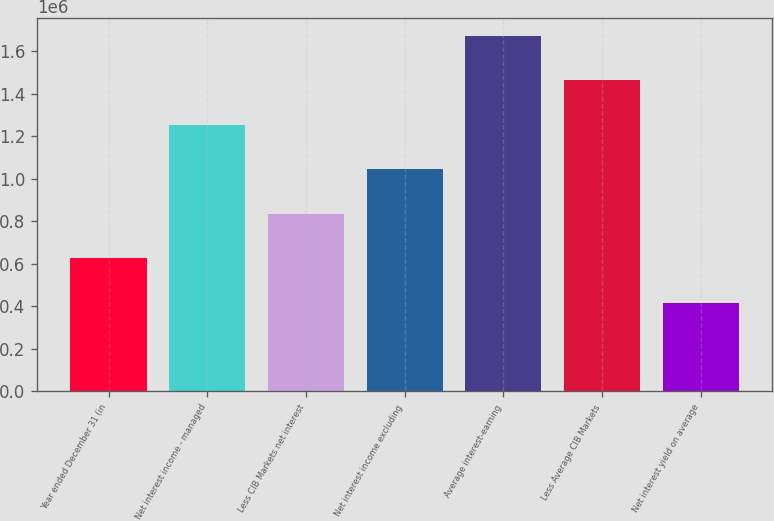Convert chart to OTSL. <chart><loc_0><loc_0><loc_500><loc_500><bar_chart><fcel>Year ended December 31 (in<fcel>Net interest income - managed<fcel>Less CIB Markets net interest<fcel>Net interest income excluding<fcel>Average interest-earning<fcel>Less Average CIB Markets<fcel>Net interest yield on average<nl><fcel>626473<fcel>1.25295e+06<fcel>835297<fcel>1.04412e+06<fcel>1.67059e+06<fcel>1.46177e+06<fcel>417649<nl></chart> 